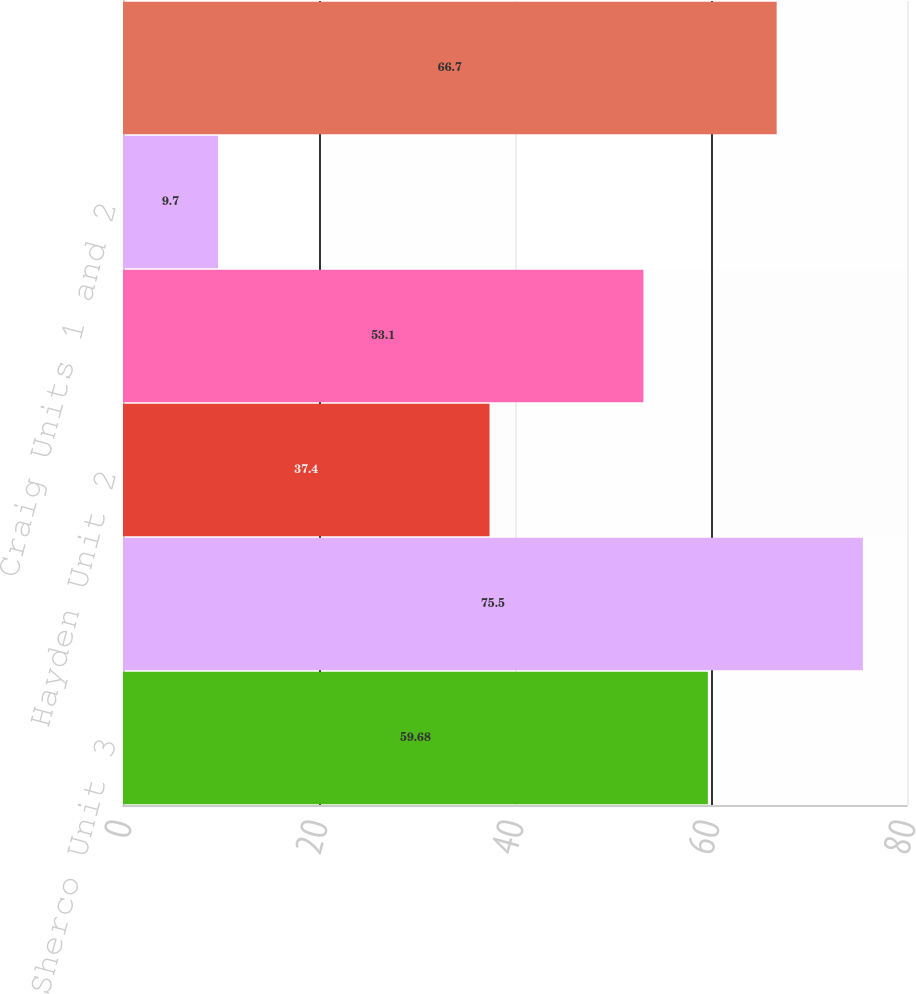Convert chart. <chart><loc_0><loc_0><loc_500><loc_500><bar_chart><fcel>Sherco Unit 3<fcel>Hayden Unit 1<fcel>Hayden Unit 2<fcel>Hayden common facilities<fcel>Craig Units 1 and 2<fcel>Comanche Unit 3<nl><fcel>59.68<fcel>75.5<fcel>37.4<fcel>53.1<fcel>9.7<fcel>66.7<nl></chart> 